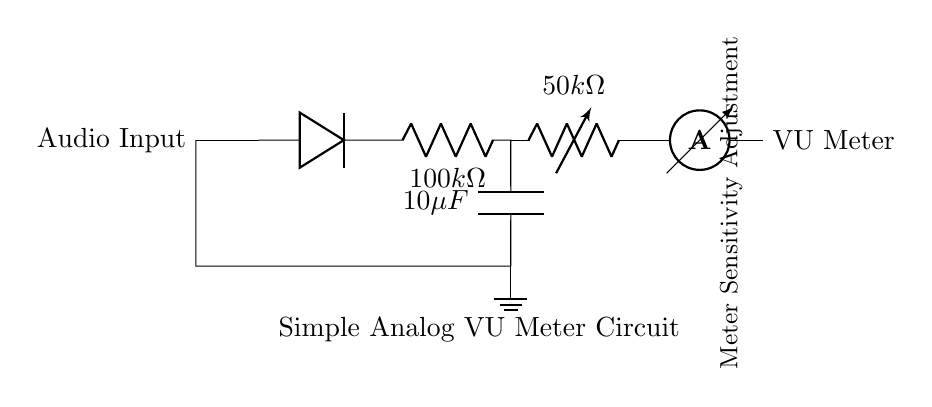What type of diode is used in this circuit? The circuit includes a diode, which is typically used for rectification. The question asks for the type of diode but does not specify a particular model; thus, it generally refers to a standard diode.
Answer: Diode What is the resistance value of R1? R1 is labeled as having a resistance of 100k ohms in the diagram, which is a direct read from the circuit components.
Answer: 100k ohm Where do the audio levels get monitored? The VU Meter is identified in the circuit as the component that indicates audio levels visually. It is connected after the rectifier circuit, allowing it to reflect the audio levels processed.
Answer: VU Meter What is the purpose of C1? Capacitor C1 is used for filtering in this circuit, smoothing out the rectified signal so that the VU Meter can display more stable audio levels. Its function is to reduce fluctuations and noise in the signal.
Answer: Filtering How can you adjust the sensitivity of this circuit? The circuit features a variable resistor VR1, which is specifically labeled as "Meter Sensitivity Adjustment." This component allows users to change the impedance, thus tuning the sensitivity of the VU Meter reading.
Answer: VR1 What kind of current flows through the ammeter? The ammeter in this circuit measures the output current after the rectification and filtering process, providing a reading of how much current correlates to the audio signal levels. This configuration determines audio levels during recording sessions.
Answer: Output current What is the value of C1? C1 is indicated in the circuit as having a capacitance value of 10 microfarads, which is a standard specification labeled directly on the component in the diagram.
Answer: 10 microfarads 